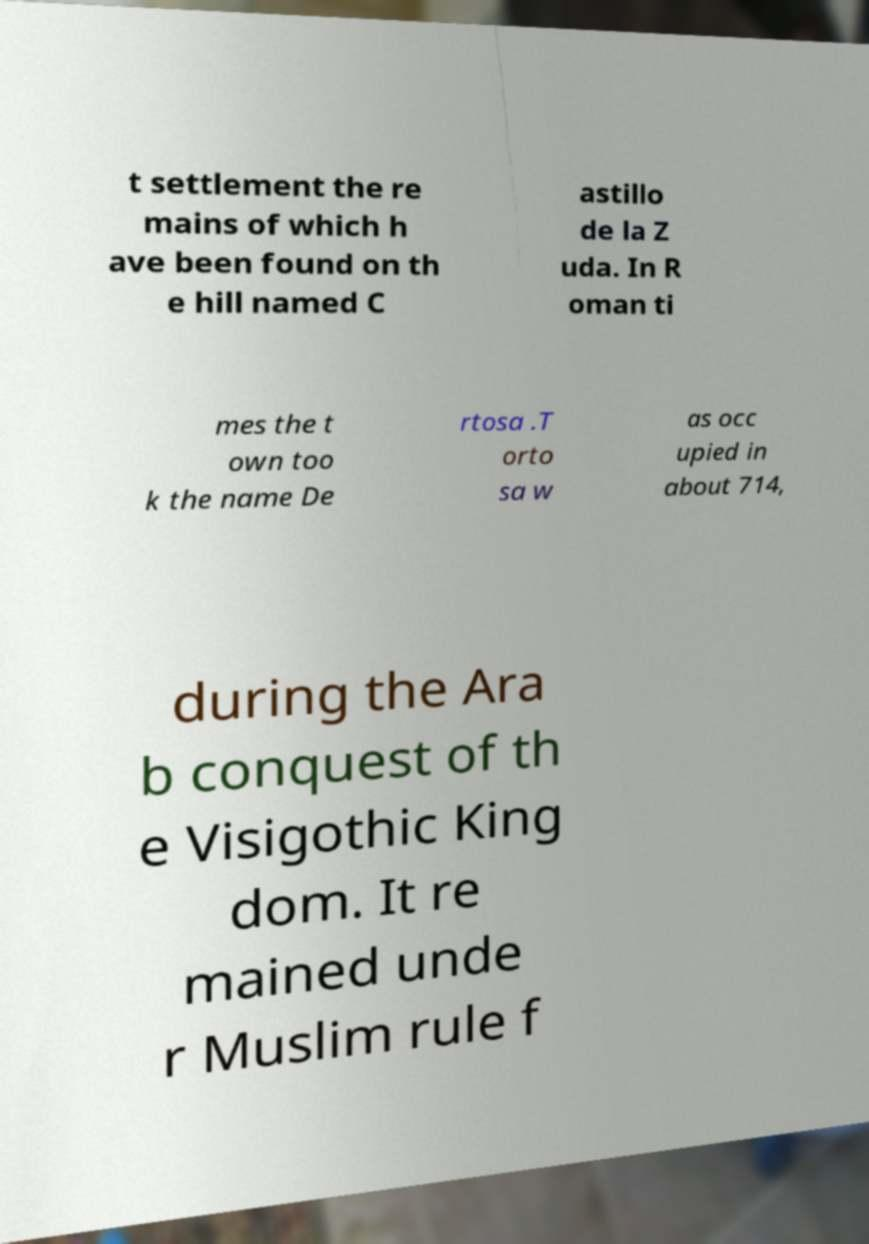What messages or text are displayed in this image? I need them in a readable, typed format. t settlement the re mains of which h ave been found on th e hill named C astillo de la Z uda. In R oman ti mes the t own too k the name De rtosa .T orto sa w as occ upied in about 714, during the Ara b conquest of th e Visigothic King dom. It re mained unde r Muslim rule f 